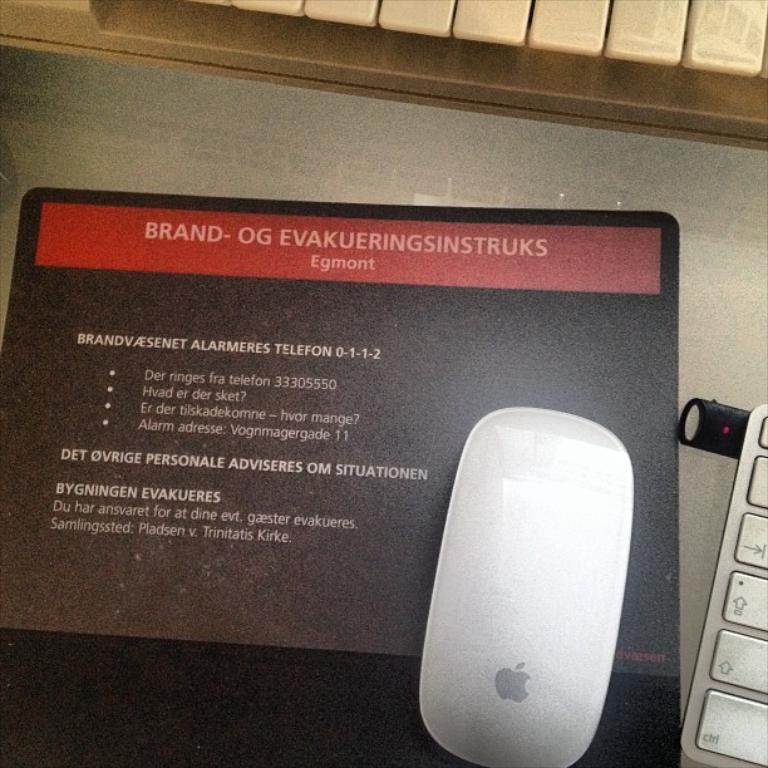How would you summarize this image in a sentence or two? In the image I can see mouse, keyboard, mouse pad and something written on it. 